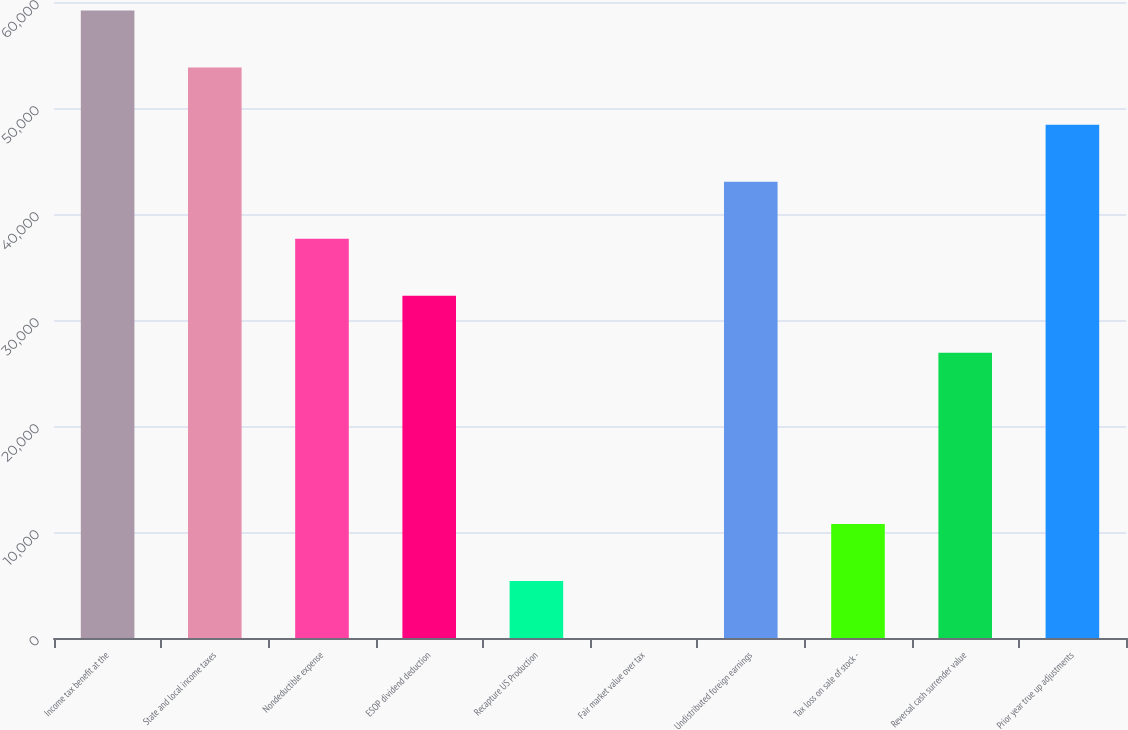Convert chart to OTSL. <chart><loc_0><loc_0><loc_500><loc_500><bar_chart><fcel>Income tax benefit at the<fcel>State and local income taxes<fcel>Nondeductible expense<fcel>ESOP dividend deduction<fcel>Recapture US Production<fcel>Fair market value over tax<fcel>Undistributed foreign earnings<fcel>Tax loss on sale of stock -<fcel>Reversal cash surrender value<fcel>Prior year true up adjustments<nl><fcel>59189.7<fcel>53809<fcel>37667<fcel>32286.3<fcel>5383.05<fcel>2.39<fcel>43047.7<fcel>10763.7<fcel>26905.7<fcel>48428.3<nl></chart> 